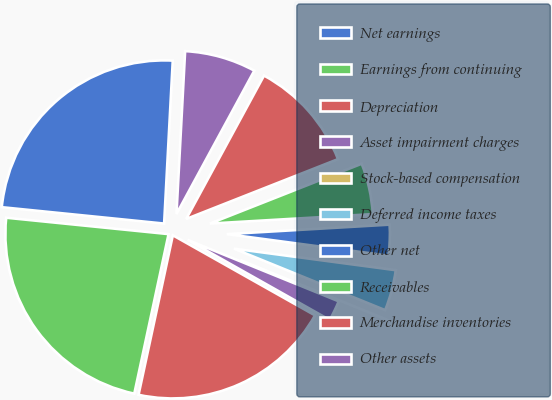Convert chart to OTSL. <chart><loc_0><loc_0><loc_500><loc_500><pie_chart><fcel>Net earnings<fcel>Earnings from continuing<fcel>Depreciation<fcel>Asset impairment charges<fcel>Stock-based compensation<fcel>Deferred income taxes<fcel>Other net<fcel>Receivables<fcel>Merchandise inventories<fcel>Other assets<nl><fcel>24.24%<fcel>23.23%<fcel>20.2%<fcel>2.02%<fcel>0.0%<fcel>4.04%<fcel>3.03%<fcel>5.05%<fcel>11.11%<fcel>7.07%<nl></chart> 